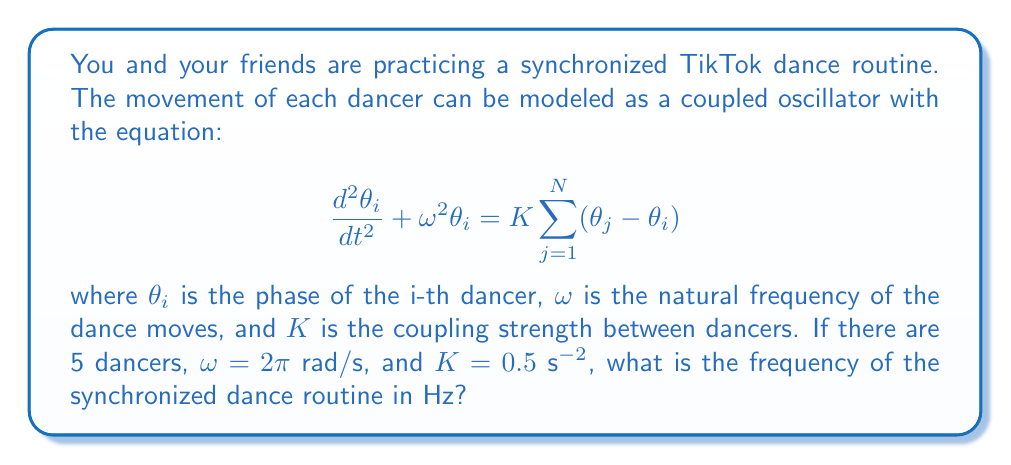What is the answer to this math problem? Let's approach this step-by-step:

1) In a fully synchronized state, all dancers move with the same frequency. This frequency is different from the natural frequency $\omega$ due to the coupling between dancers.

2) For a system of N coupled oscillators, the synchronized frequency $\Omega$ is given by:

   $$\Omega = \sqrt{\omega^2 + NK}$$

3) In this case:
   - N = 5 (number of dancers)
   - $\omega = 2\pi$ rad/s
   - K = 0.5 s^(-2)

4) Let's substitute these values into the equation:

   $$\Omega = \sqrt{(2\pi)^2 + 5(0.5)}$$

5) Simplify:
   
   $$\Omega = \sqrt{4\pi^2 + 2.5}$$

6) Calculate:
   
   $$\Omega \approx 6.3830 \text{ rad/s}$$

7) To convert from rad/s to Hz, we divide by $2\pi$:

   $$f = \frac{\Omega}{2\pi} \approx 1.0159 \text{ Hz}$$

Thus, the synchronized dance routine will have a frequency of approximately 1.0159 Hz.
Answer: 1.0159 Hz 